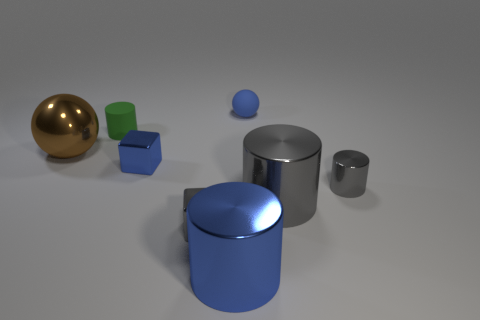Which objects are reflective, and what can you infer from their surfaces? In the image, the cylinders and the gold sphere are highly reflective, indicating that they have a smooth, possibly metallic finish. These shiny surfaces are likely to be polished metal or a material with a similar reflective property. The presence of reflection and highlights on these objects suggests a source of light in the environment, although it is not directly visible in the frame. 